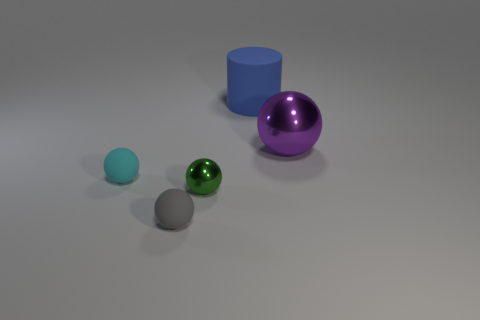How many gray matte objects are behind the object right of the thing that is behind the large sphere?
Offer a terse response. 0. How big is the purple object?
Your response must be concise. Large. There is a blue object that is the same size as the purple shiny object; what material is it?
Offer a terse response. Rubber. There is a cyan sphere; what number of blue things are in front of it?
Give a very brief answer. 0. Is the tiny thing left of the small gray rubber thing made of the same material as the small green ball that is to the left of the big metal object?
Provide a succinct answer. No. What is the shape of the matte thing right of the shiny object left of the sphere that is behind the cyan rubber object?
Give a very brief answer. Cylinder. The big purple object is what shape?
Your answer should be very brief. Sphere. What is the shape of the rubber thing that is the same size as the purple sphere?
Your response must be concise. Cylinder. Do the metal thing that is behind the tiny cyan sphere and the shiny thing in front of the large purple metallic object have the same shape?
Offer a terse response. Yes. What number of objects are either rubber objects in front of the cyan matte thing or spheres that are to the left of the big blue rubber object?
Your response must be concise. 3. 